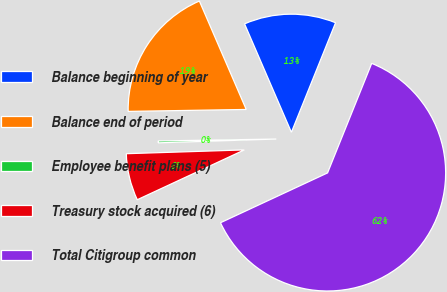Convert chart to OTSL. <chart><loc_0><loc_0><loc_500><loc_500><pie_chart><fcel>Balance beginning of year<fcel>Balance end of period<fcel>Employee benefit plans (5)<fcel>Treasury stock acquired (6)<fcel>Total Citigroup common<nl><fcel>12.59%<fcel>18.77%<fcel>0.25%<fcel>6.42%<fcel>61.97%<nl></chart> 